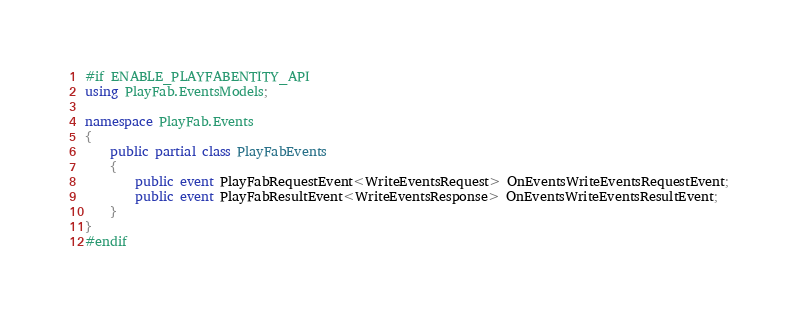<code> <loc_0><loc_0><loc_500><loc_500><_C#_>#if ENABLE_PLAYFABENTITY_API
using PlayFab.EventsModels;

namespace PlayFab.Events
{
    public partial class PlayFabEvents
    {
        public event PlayFabRequestEvent<WriteEventsRequest> OnEventsWriteEventsRequestEvent;
        public event PlayFabResultEvent<WriteEventsResponse> OnEventsWriteEventsResultEvent;
    }
}
#endif
</code> 